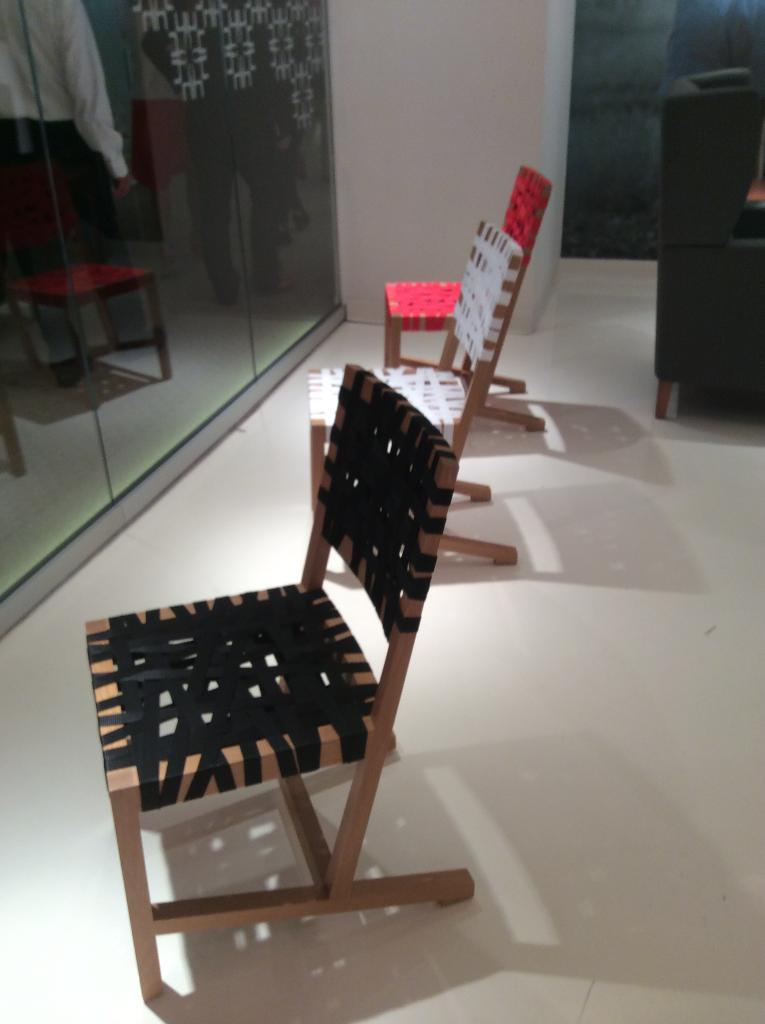What objects are on the floor in the image? There are chairs on the floor in the image. What is visible in the background of the image? There is a wall in the image. What can be seen in the glasses on the left side of the image? There are reflections of persons and chairs in the glasses on the left side of the image. What type of tongue can be seen sticking out from the edge of the wall in the image? There is no tongue visible in the image, and the wall does not have an edge. 